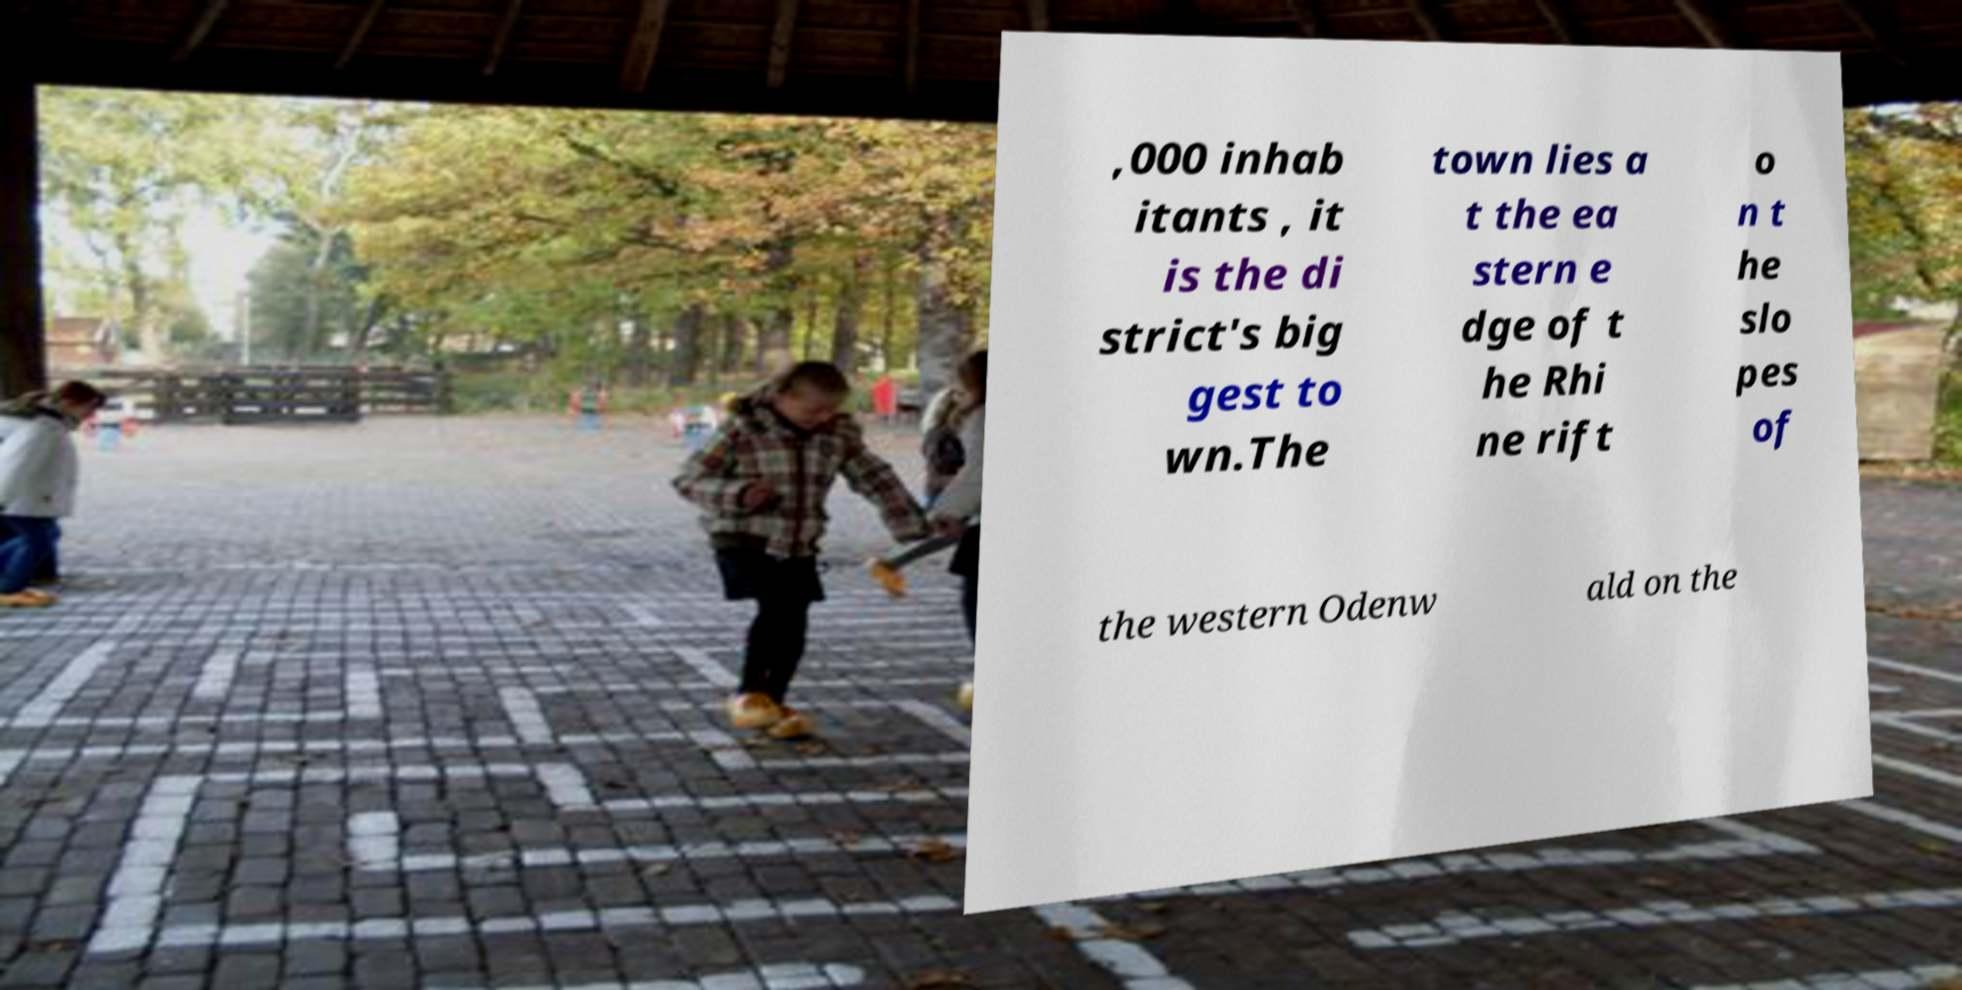Please identify and transcribe the text found in this image. ,000 inhab itants , it is the di strict's big gest to wn.The town lies a t the ea stern e dge of t he Rhi ne rift o n t he slo pes of the western Odenw ald on the 